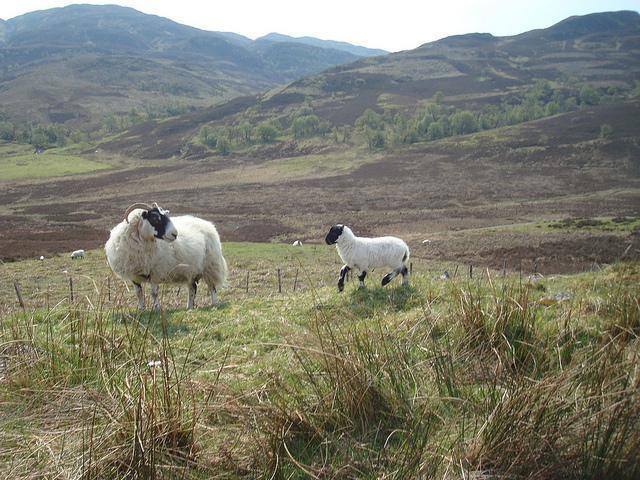How many sheep are grazing?
Give a very brief answer. 2. How many sheep are pictured?
Give a very brief answer. 2. How many sheep are in the picture?
Give a very brief answer. 2. 